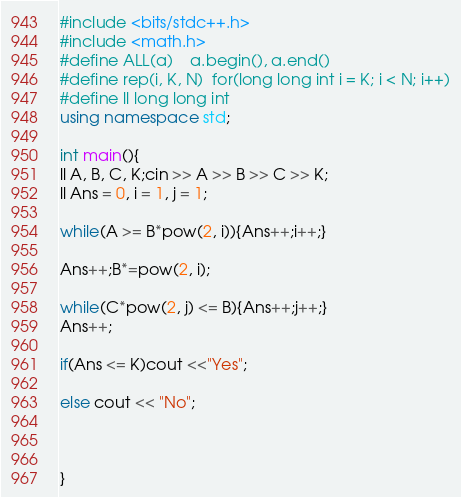<code> <loc_0><loc_0><loc_500><loc_500><_C++_>#include <bits/stdc++.h>
#include <math.h>
#define ALL(a)    a.begin(), a.end() 
#define rep(i, K, N)  for(long long int i = K; i < N; i++)
#define ll long long int
using namespace std;

int main(){
ll A, B, C, K;cin >> A >> B >> C >> K;
ll Ans = 0, i = 1, j = 1;

while(A >= B*pow(2, i)){Ans++;i++;}

Ans++;B*=pow(2, i);

while(C*pow(2, j) <= B){Ans++;j++;}
Ans++;

if(Ans <= K)cout <<"Yes";

else cout << "No";



}</code> 